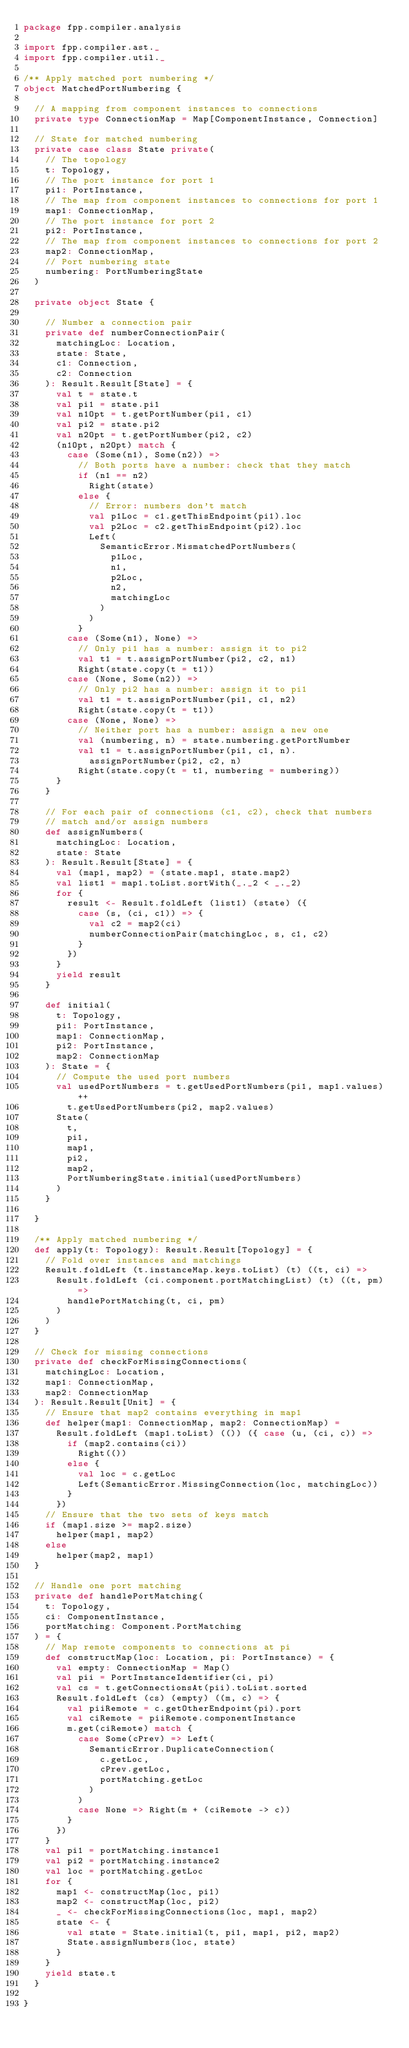<code> <loc_0><loc_0><loc_500><loc_500><_Scala_>package fpp.compiler.analysis

import fpp.compiler.ast._
import fpp.compiler.util._

/** Apply matched port numbering */
object MatchedPortNumbering {

  // A mapping from component instances to connections
  private type ConnectionMap = Map[ComponentInstance, Connection]

  // State for matched numbering
  private case class State private(
    // The topology
    t: Topology,
    // The port instance for port 1
    pi1: PortInstance,
    // The map from component instances to connections for port 1
    map1: ConnectionMap,
    // The port instance for port 2
    pi2: PortInstance,
    // The map from component instances to connections for port 2
    map2: ConnectionMap,
    // Port numbering state
    numbering: PortNumberingState
  )

  private object State {

    // Number a connection pair
    private def numberConnectionPair(
      matchingLoc: Location,
      state: State,
      c1: Connection,
      c2: Connection
    ): Result.Result[State] = {
      val t = state.t
      val pi1 = state.pi1
      val n1Opt = t.getPortNumber(pi1, c1)
      val pi2 = state.pi2
      val n2Opt = t.getPortNumber(pi2, c2)
      (n1Opt, n2Opt) match {
        case (Some(n1), Some(n2)) =>
          // Both ports have a number: check that they match
          if (n1 == n2)
            Right(state)
          else {
            // Error: numbers don't match
            val p1Loc = c1.getThisEndpoint(pi1).loc
            val p2Loc = c2.getThisEndpoint(pi2).loc
            Left(
              SemanticError.MismatchedPortNumbers(
                p1Loc,
                n1,
                p2Loc,
                n2,
                matchingLoc
              )
            )
          }
        case (Some(n1), None) =>
          // Only pi1 has a number: assign it to pi2
          val t1 = t.assignPortNumber(pi2, c2, n1)
          Right(state.copy(t = t1))
        case (None, Some(n2)) =>
          // Only pi2 has a number: assign it to pi1
          val t1 = t.assignPortNumber(pi1, c1, n2)
          Right(state.copy(t = t1))
        case (None, None) =>
          // Neither port has a number: assign a new one
          val (numbering, n) = state.numbering.getPortNumber
          val t1 = t.assignPortNumber(pi1, c1, n).
            assignPortNumber(pi2, c2, n)
          Right(state.copy(t = t1, numbering = numbering))
      }
    }

    // For each pair of connections (c1, c2), check that numbers 
    // match and/or assign numbers
    def assignNumbers(
      matchingLoc: Location,
      state: State
    ): Result.Result[State] = {
      val (map1, map2) = (state.map1, state.map2)
      val list1 = map1.toList.sortWith(_._2 < _._2)
      for {
        result <- Result.foldLeft (list1) (state) ({
          case (s, (ci, c1)) => {
            val c2 = map2(ci)
            numberConnectionPair(matchingLoc, s, c1, c2)
          }
        })
      }
      yield result
    }

    def initial(
      t: Topology,
      pi1: PortInstance,
      map1: ConnectionMap,
      pi2: PortInstance,
      map2: ConnectionMap
    ): State = {
      // Compute the used port numbers
      val usedPortNumbers = t.getUsedPortNumbers(pi1, map1.values) ++
        t.getUsedPortNumbers(pi2, map2.values)
      State(
        t,
        pi1,
        map1,
        pi2,
        map2,
        PortNumberingState.initial(usedPortNumbers)
      )
    }

  }

  /** Apply matched numbering */
  def apply(t: Topology): Result.Result[Topology] = {
    // Fold over instances and matchings
    Result.foldLeft (t.instanceMap.keys.toList) (t) ((t, ci) =>
      Result.foldLeft (ci.component.portMatchingList) (t) ((t, pm) =>
        handlePortMatching(t, ci, pm)
      )
    )
  }

  // Check for missing connections
  private def checkForMissingConnections(
    matchingLoc: Location,
    map1: ConnectionMap,
    map2: ConnectionMap
  ): Result.Result[Unit] = {
    // Ensure that map2 contains everything in map1
    def helper(map1: ConnectionMap, map2: ConnectionMap) =
      Result.foldLeft (map1.toList) (()) ({ case (u, (ci, c)) =>
        if (map2.contains(ci))
          Right(())
        else {
          val loc = c.getLoc
          Left(SemanticError.MissingConnection(loc, matchingLoc))
        }
      })
    // Ensure that the two sets of keys match
    if (map1.size >= map2.size)
      helper(map1, map2)
    else
      helper(map2, map1)
  }

  // Handle one port matching
  private def handlePortMatching(
    t: Topology,
    ci: ComponentInstance,
    portMatching: Component.PortMatching
  ) = {
    // Map remote components to connections at pi
    def constructMap(loc: Location, pi: PortInstance) = {
      val empty: ConnectionMap = Map()
      val pii = PortInstanceIdentifier(ci, pi)
      val cs = t.getConnectionsAt(pii).toList.sorted
      Result.foldLeft (cs) (empty) ((m, c) => {
        val piiRemote = c.getOtherEndpoint(pi).port
        val ciRemote = piiRemote.componentInstance
        m.get(ciRemote) match {
          case Some(cPrev) => Left(
            SemanticError.DuplicateConnection(
              c.getLoc,
              cPrev.getLoc,
              portMatching.getLoc
            )
          )
          case None => Right(m + (ciRemote -> c))
        }
      })
    }
    val pi1 = portMatching.instance1
    val pi2 = portMatching.instance2
    val loc = portMatching.getLoc
    for {
      map1 <- constructMap(loc, pi1)
      map2 <- constructMap(loc, pi2)
      _ <- checkForMissingConnections(loc, map1, map2)
      state <- {
        val state = State.initial(t, pi1, map1, pi2, map2)
        State.assignNumbers(loc, state)
      }
    }
    yield state.t
  }

}
</code> 